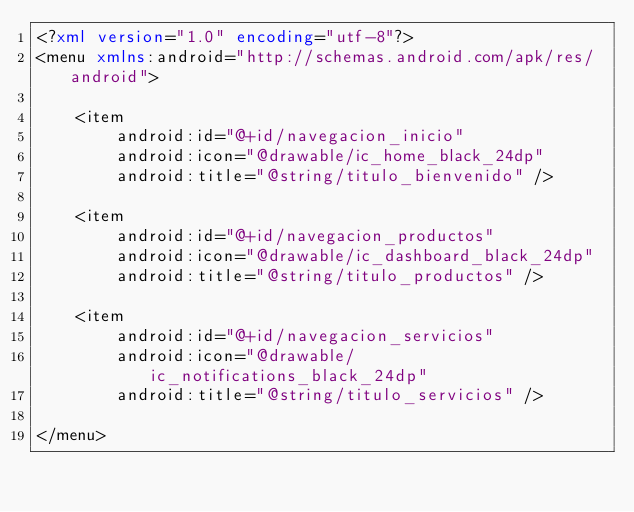<code> <loc_0><loc_0><loc_500><loc_500><_XML_><?xml version="1.0" encoding="utf-8"?>
<menu xmlns:android="http://schemas.android.com/apk/res/android">

    <item
        android:id="@+id/navegacion_inicio"
        android:icon="@drawable/ic_home_black_24dp"
        android:title="@string/titulo_bienvenido" />

    <item
        android:id="@+id/navegacion_productos"
        android:icon="@drawable/ic_dashboard_black_24dp"
        android:title="@string/titulo_productos" />

    <item
        android:id="@+id/navegacion_servicios"
        android:icon="@drawable/ic_notifications_black_24dp"
        android:title="@string/titulo_servicios" />

</menu></code> 